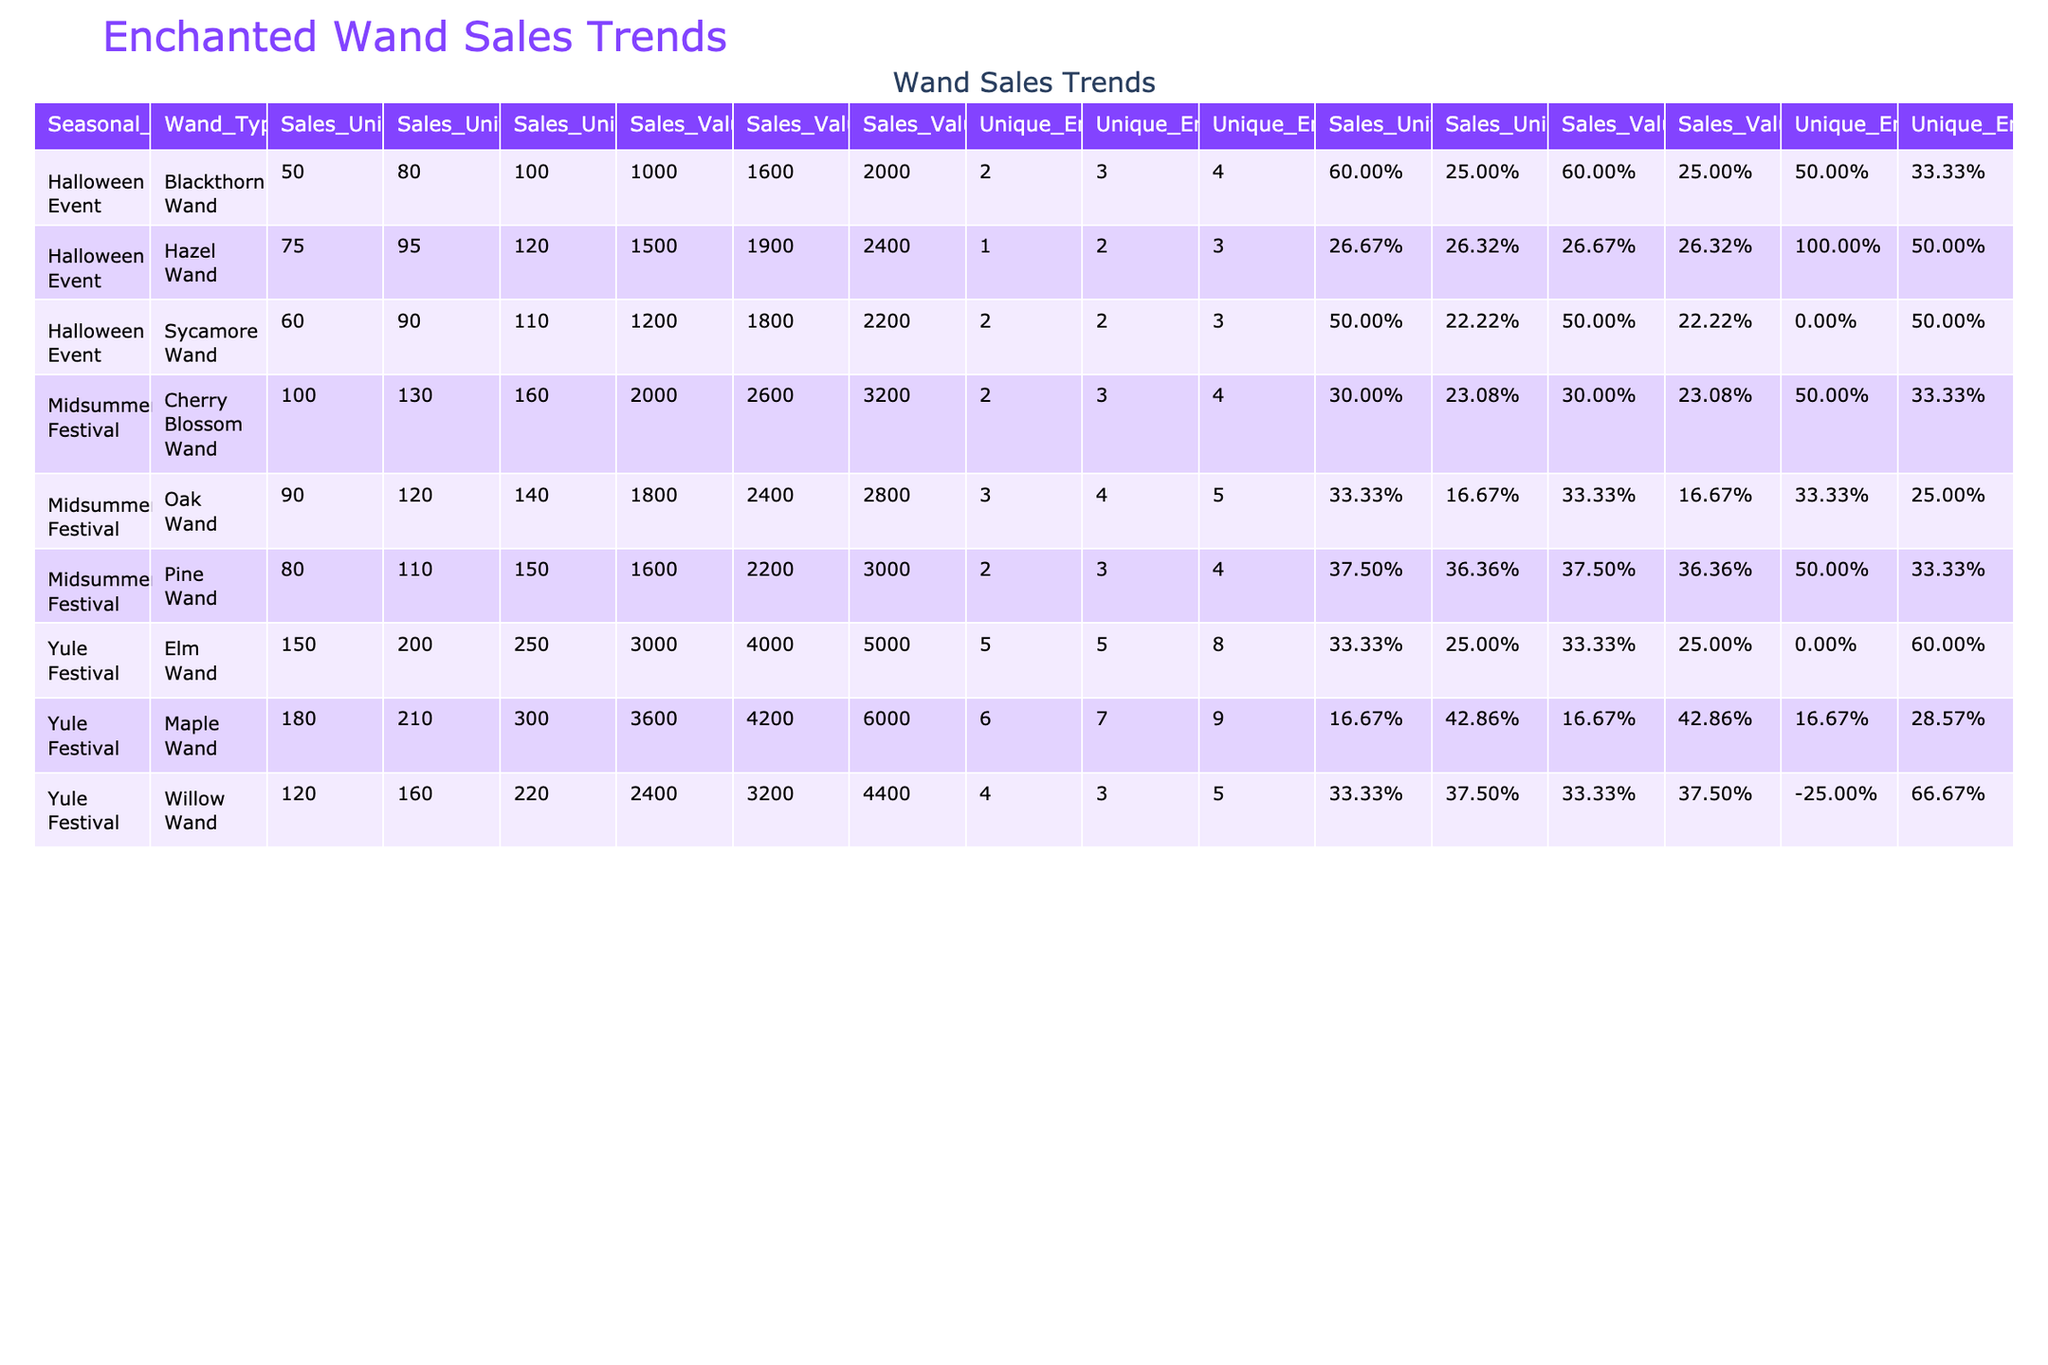What was the total sales value of Elm Wands sold during the Yule Festival in 2023? The sales value for Elm Wands in 2023 is listed as 5000.
Answer: 5000 Which wand type had the highest sales units during the Midsummer Festival in 2022? The sales units are: Cherry Blossom Wand (130), Oak Wand (120), Pine Wand (110). Cherry Blossom Wand had the highest sales with 130 units.
Answer: Cherry Blossom Wand What is the year-over-year growth for Maple Wands sold during the Yule Festival from 2022 to 2023? Sales units for Maple Wands in 2022 was 210 and in 2023 was 300. The growth is calculated as (300 - 210) / 210 = 0.42857 or 42.86%.
Answer: 42.86% How many unique enchantments did Willow Wands have in 2022? The unique enchantments for Willow Wands in 2022 are listed as 3.
Answer: 3 Did the sales units of the Blackthorn Wand increase from 2021 to 2022? The sales units for Blackthorn Wand are: 50 in 2021 and 80 in 2022. Since 80 is greater than 50, it indicates an increase.
Answer: Yes What is the average sales value of Oak Wands sold during the Midsummer Festival over the three years? The sales values are: 1800 (2021), 2400 (2022), and 2800 (2023). Their total is 1800 + 2400 + 2800 = 7000. The average is 7000 / 3 = 2333.33.
Answer: 2333.33 Which seasonal event had the highest total sales value across all wand types in 2023? The sales values for 2023 are: Yule Festival (4400 + 5000 + 6000 = 17400), Midsummer Festival (3200 + 2800 + 3000 = 9000), Halloween Event (2400 + 2000 + 2200 = 6600). Yule Festival had the highest with 17400.
Answer: Yule Festival Calculate the percentage of sales units for Hazel Wands relative to the total sales units in the Halloween Event for 2023. The sales units for Hazel Wands in 2023 is 120. The total sales units in Halloween Event 2023 are 120 + 100 + 110 = 330. The percentage is (120/330) * 100 = 36.36%.
Answer: 36.36% What was the sales unit change for Pine Wands between the Midsummer Festival in 2021 and 2023? Sales units for Pine Wands were 80 in 2021 and increased to 150 in 2023. The change is calculated as 150 - 80 = 70.
Answer: 70 Is it true that the unique enchantments for Maple Wands increased each year during the Yule Festival? The unique enchantments for Maple Wands were 6 in 2021, 7 in 2022, and 9 in 2023. Thus, they increased each year.
Answer: Yes 